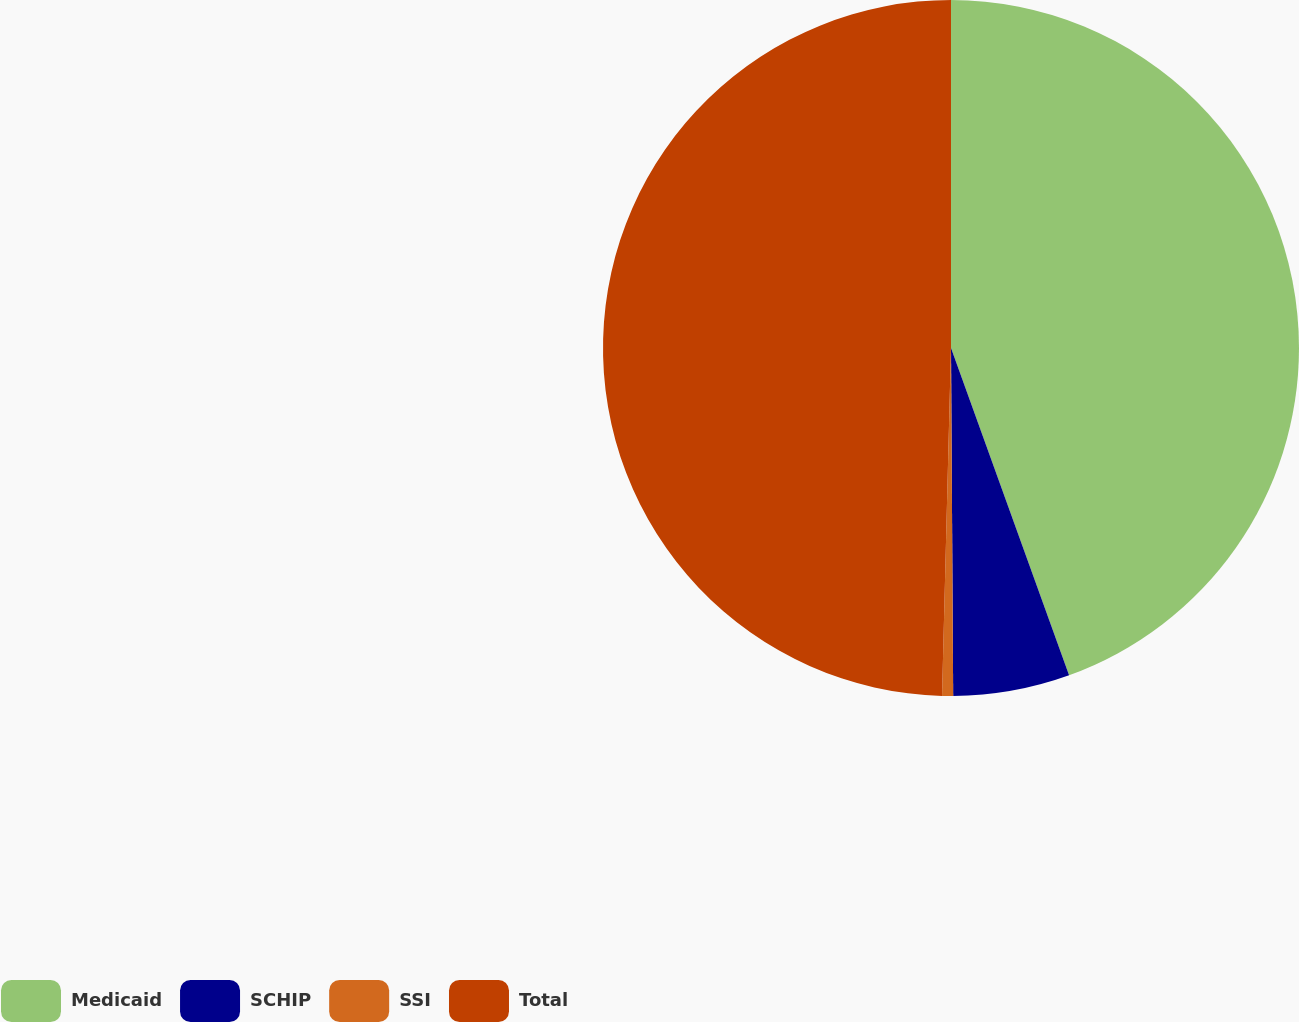Convert chart to OTSL. <chart><loc_0><loc_0><loc_500><loc_500><pie_chart><fcel>Medicaid<fcel>SCHIP<fcel>SSI<fcel>Total<nl><fcel>44.49%<fcel>5.41%<fcel>0.51%<fcel>49.59%<nl></chart> 